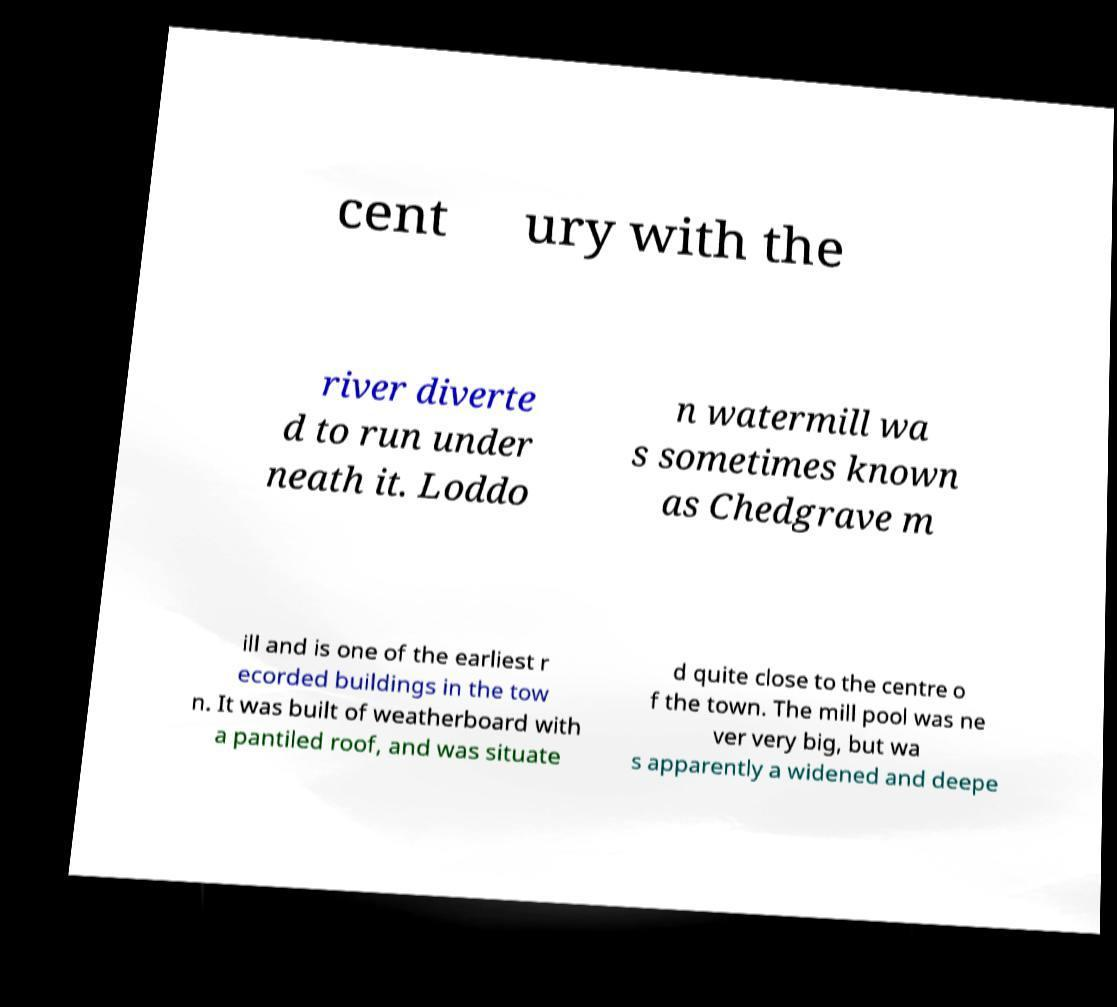Could you extract and type out the text from this image? cent ury with the river diverte d to run under neath it. Loddo n watermill wa s sometimes known as Chedgrave m ill and is one of the earliest r ecorded buildings in the tow n. It was built of weatherboard with a pantiled roof, and was situate d quite close to the centre o f the town. The mill pool was ne ver very big, but wa s apparently a widened and deepe 